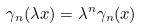<formula> <loc_0><loc_0><loc_500><loc_500>\gamma _ { n } ( \lambda x ) = \lambda ^ { n } \gamma _ { n } ( x )</formula> 